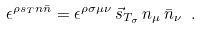Convert formula to latex. <formula><loc_0><loc_0><loc_500><loc_500>\epsilon ^ { \rho s _ { T } n \bar { n } } = \epsilon ^ { \rho \sigma \mu \nu } \, \vec { s } _ { T _ { \sigma } } \, n _ { \mu } \, \bar { n } _ { \nu } \ .</formula> 